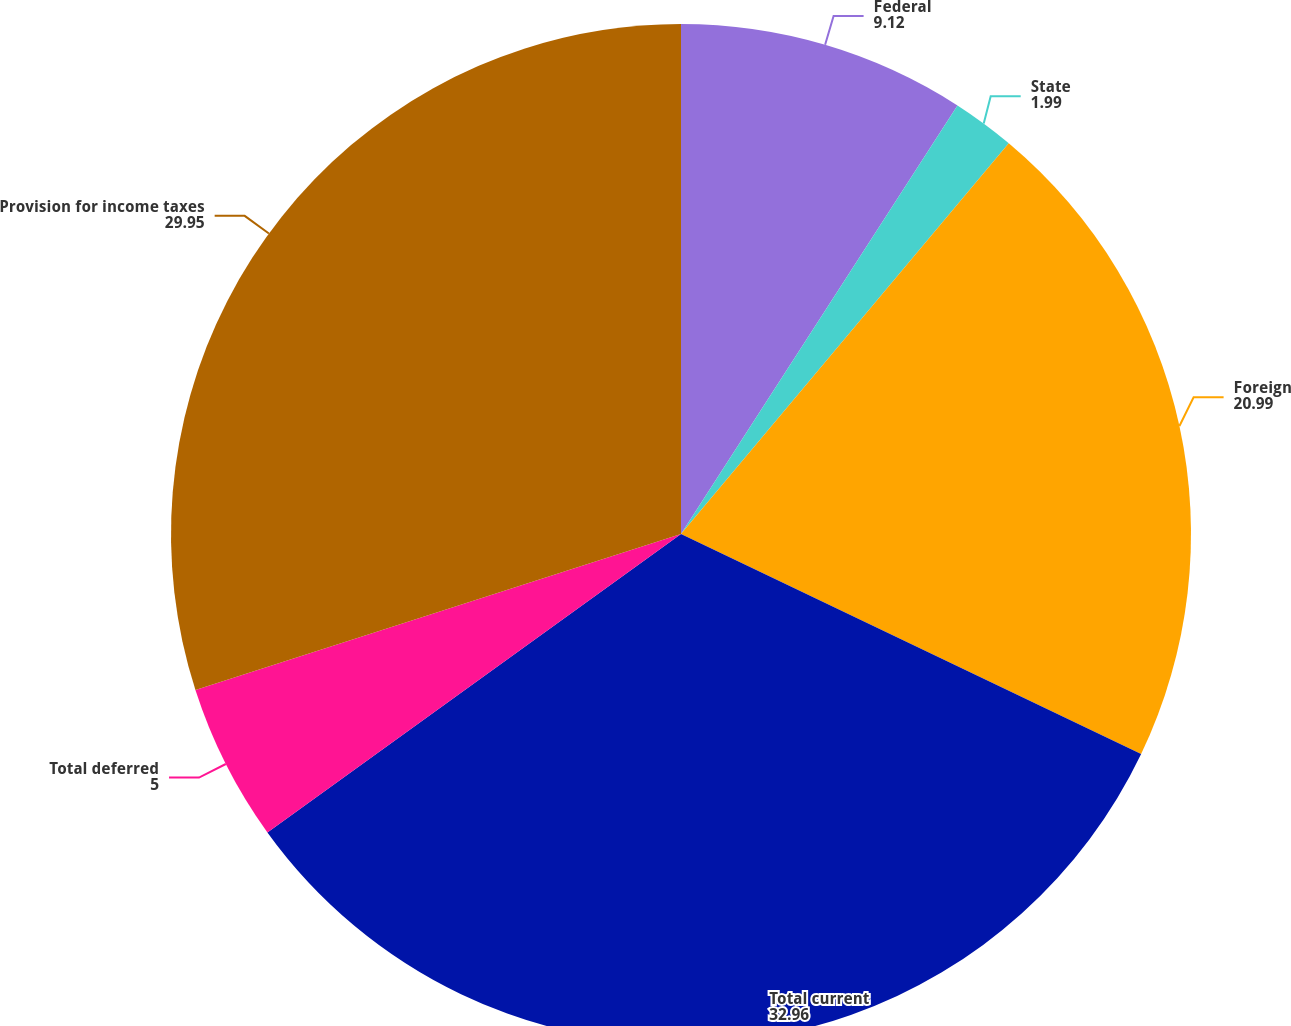Convert chart. <chart><loc_0><loc_0><loc_500><loc_500><pie_chart><fcel>Federal<fcel>State<fcel>Foreign<fcel>Total current<fcel>Total deferred<fcel>Provision for income taxes<nl><fcel>9.12%<fcel>1.99%<fcel>20.99%<fcel>32.96%<fcel>5.0%<fcel>29.95%<nl></chart> 